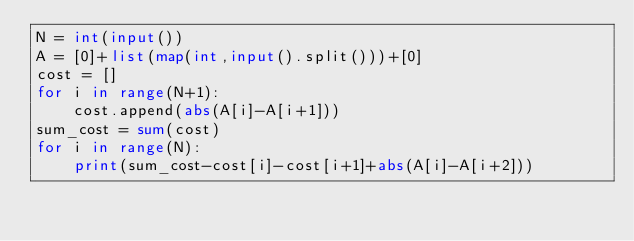<code> <loc_0><loc_0><loc_500><loc_500><_Python_>N = int(input())
A = [0]+list(map(int,input().split()))+[0]
cost = []
for i in range(N+1):
    cost.append(abs(A[i]-A[i+1]))
sum_cost = sum(cost)
for i in range(N):
    print(sum_cost-cost[i]-cost[i+1]+abs(A[i]-A[i+2]))</code> 